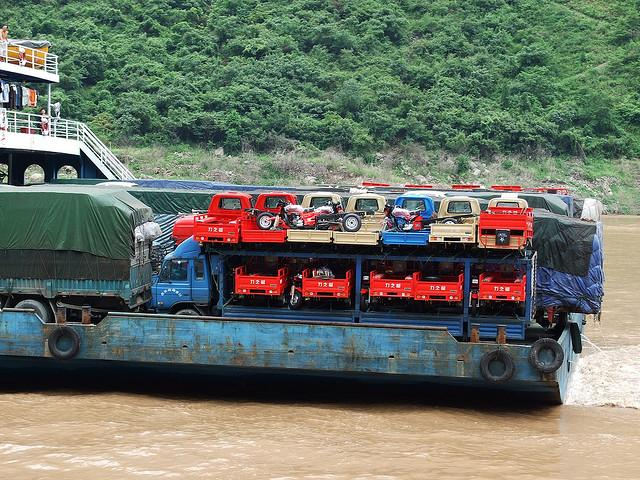Why are all the trucks in back of the boat? hauling them 